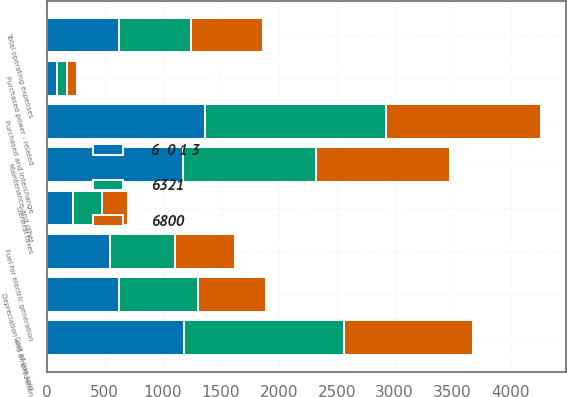<chart> <loc_0><loc_0><loc_500><loc_500><stacked_bar_chart><ecel><fcel>Fuel for electric generation<fcel>Purchased and interchange<fcel>Purchased power - related<fcel>Cost of gas sold<fcel>Maintenance and other<fcel>Depreciation and amortization<fcel>General taxes<fcel>Total operating expenses<nl><fcel>6321<fcel>567<fcel>1564<fcel>89<fcel>1375<fcel>1146<fcel>678<fcel>246<fcel>622<nl><fcel>6  0 1 3<fcel>541<fcel>1361<fcel>89<fcel>1187<fcel>1174<fcel>622<fcel>229<fcel>622<nl><fcel>6800<fcel>517<fcel>1339<fcel>86<fcel>1110<fcel>1162<fcel>592<fcel>223<fcel>622<nl></chart> 